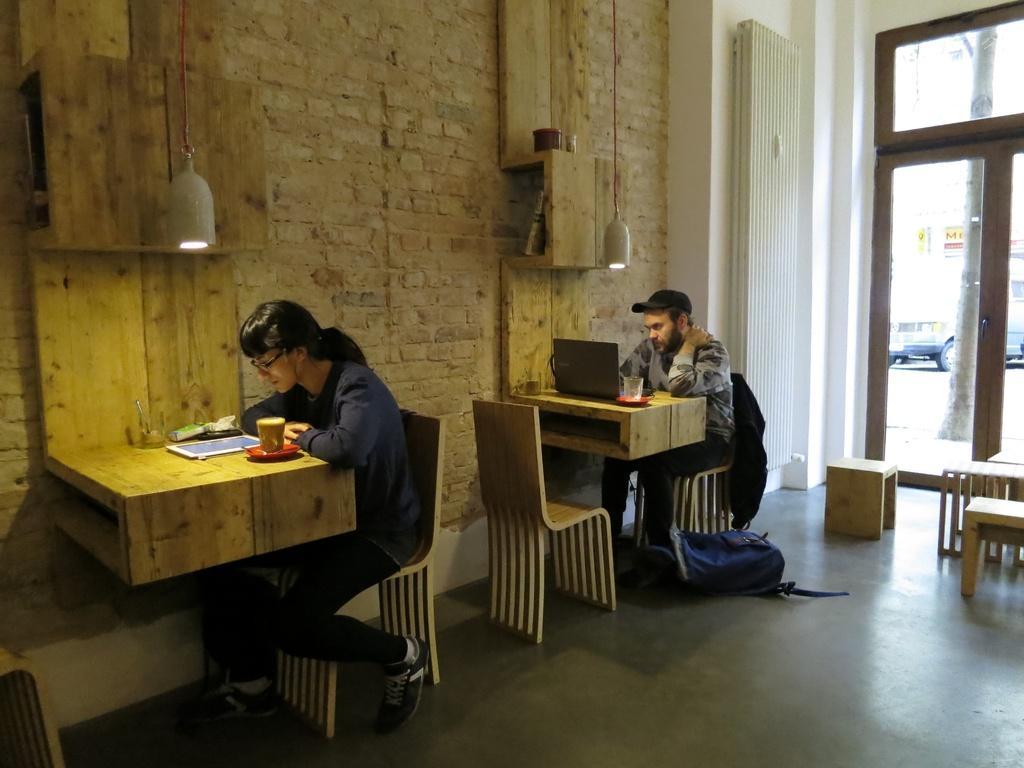Please provide a concise description of this image. In this we can see a person is sitting on the chair, and in front her is the table, and laptop and some objects on it, and here is the light, and here is the wall made of bricks, and here is the bag on the floor, and here is the door. 